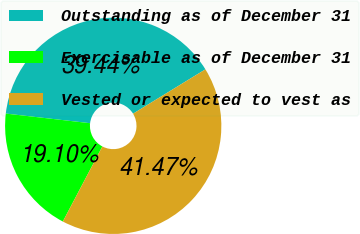Convert chart. <chart><loc_0><loc_0><loc_500><loc_500><pie_chart><fcel>Outstanding as of December 31<fcel>Exercisable as of December 31<fcel>Vested or expected to vest as<nl><fcel>39.44%<fcel>19.1%<fcel>41.47%<nl></chart> 